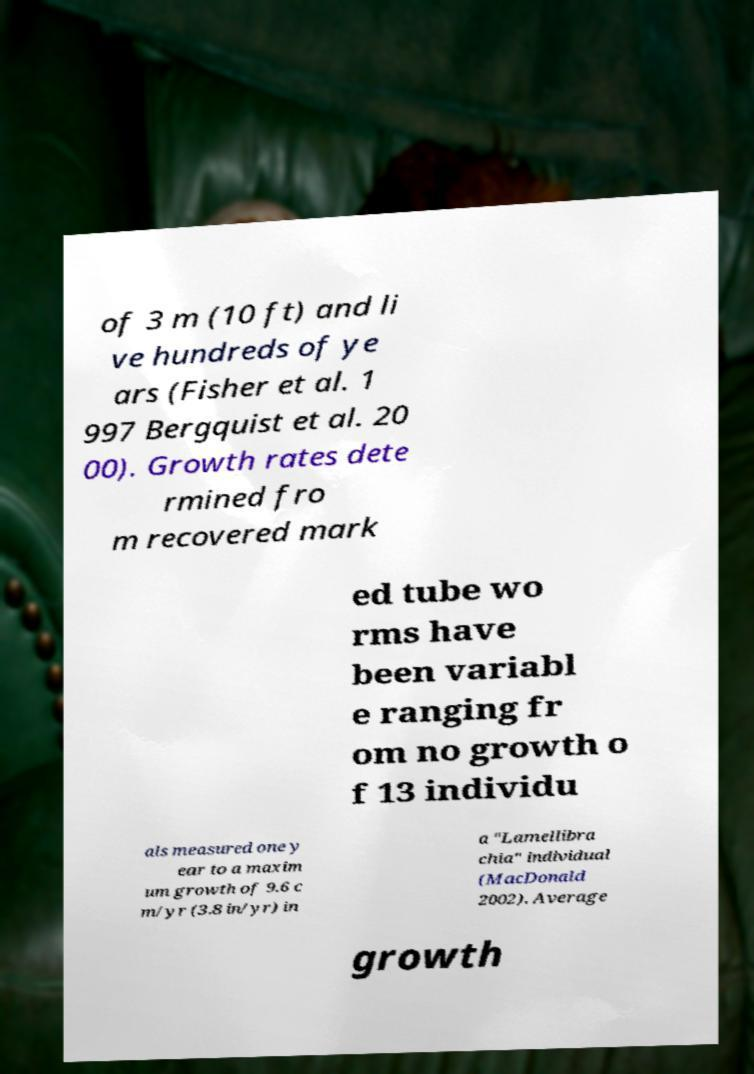Can you accurately transcribe the text from the provided image for me? of 3 m (10 ft) and li ve hundreds of ye ars (Fisher et al. 1 997 Bergquist et al. 20 00). Growth rates dete rmined fro m recovered mark ed tube wo rms have been variabl e ranging fr om no growth o f 13 individu als measured one y ear to a maxim um growth of 9.6 c m/yr (3.8 in/yr) in a "Lamellibra chia" individual (MacDonald 2002). Average growth 